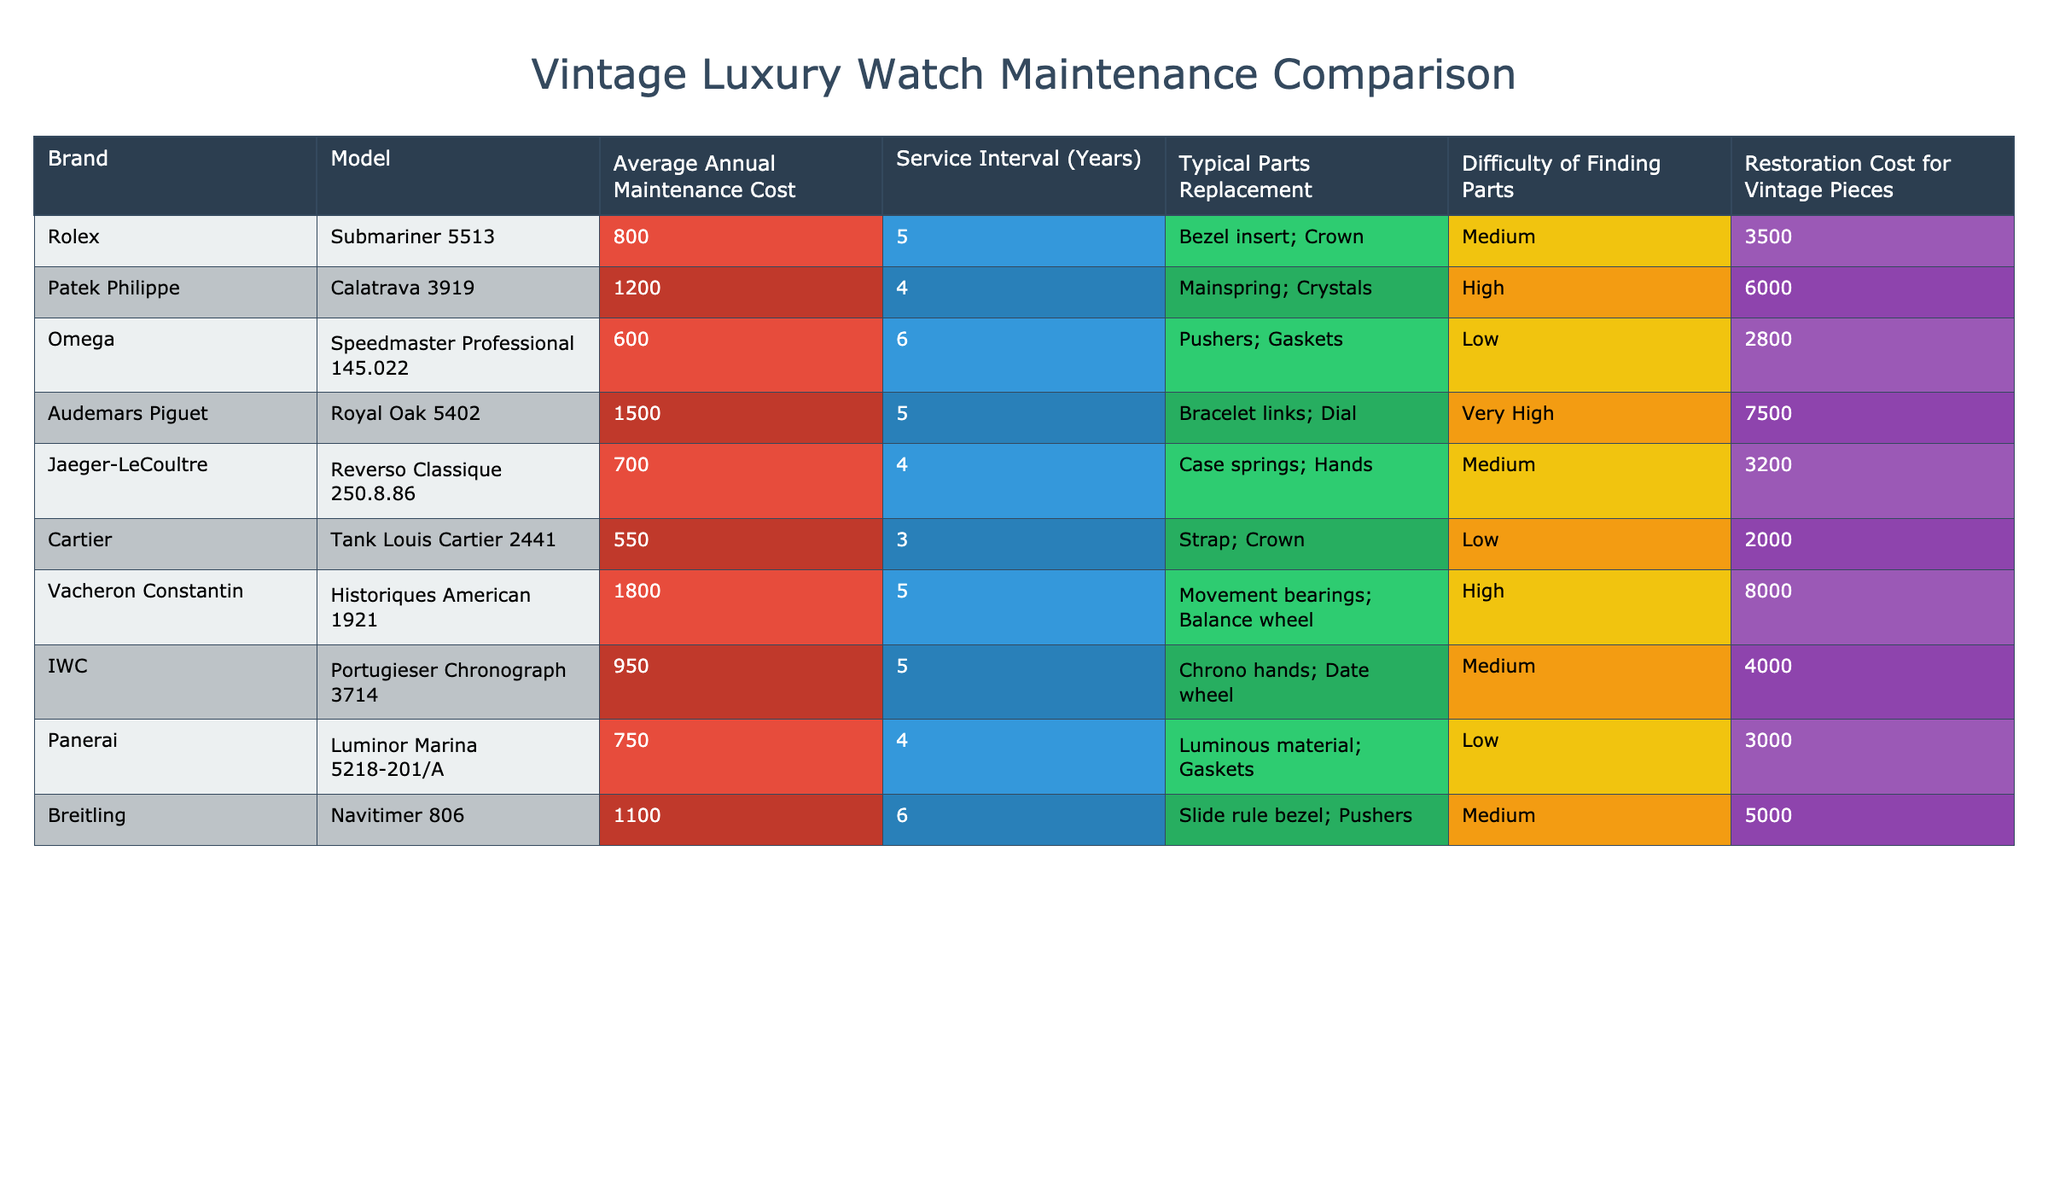What is the average annual maintenance cost for an Omega Speedmaster Professional 145.022? The table indicates that the average annual maintenance cost for the Omega Speedmaster Professional 145.022 is listed in the corresponding row under "Average Annual Maintenance Cost," which shows a value of 600.
Answer: 600 Which brand has the highest restoration cost for vintage pieces? By examining the "Restoration Cost for Vintage Pieces" column, the highest value found is 8000, which corresponds to the brand Vacheron Constantin.
Answer: Vacheron Constantin How many years does a Rolex Submariner 5513 typically go before needing a service? The "Service Interval (Years)" column for Rolex Submariner 5513 shows a value of 5 years, indicating this is the typical duration before service is needed.
Answer: 5 Is the average annual maintenance cost for a Jaeger-LeCoultre Reverso Classique 250.8.86 higher than that for a Cartier Tank Louis Cartier 2441? The average annual maintenance cost for Jaeger-LeCoultre is 700, while for Cartier it is 550. Since 700 is greater than 550, the statement is true.
Answer: Yes What is the average maintenance cost of Audemars Piguet, Rolex, and Omega combined? The individual average annual maintenance costs are: Audemars Piguet at 1500, Rolex at 800, and Omega at 600. Adding these gives 1500 + 800 + 600 = 2900. Dividing by 3 gives the average: 2900 / 3 = 966.67.
Answer: 966.67 Which brand's average annual maintenance cost is closest to the average cost of 1000 across the table? To find which brand is closest to 1000, we can check the average annual costs: 800 for Rolex, 1200 for Patek Philippe, and 950 for IWC are all considered. The nearest value is 950 for IWC at a difference of 50.
Answer: IWC True or False: The average annual maintenance cost for Patek Philippe is less than 1200. Referring to the table, the average annual maintenance cost for Patek Philippe is 1200, not less. Thus, the statement is false.
Answer: False What is the combined average annual maintenance cost of the top three most expensive brands for maintenance? The brands with the highest costs are Vacheron Constantin (1800), Audemars Piguet (1500), and Patek Philippe (1200). The combined total is 1800 + 1500 + 1200 = 4500, and thus the average is 4500 / 3 = 1500.
Answer: 1500 Which brand has the lowest typical parts replacement difficulty? Upon reviewing the "Difficulty of Finding Parts" column, it shows that both Omega and Cartier have a "Low" difficulty, which indicates they have the lowest difficulty level.
Answer: Omega and Cartier 